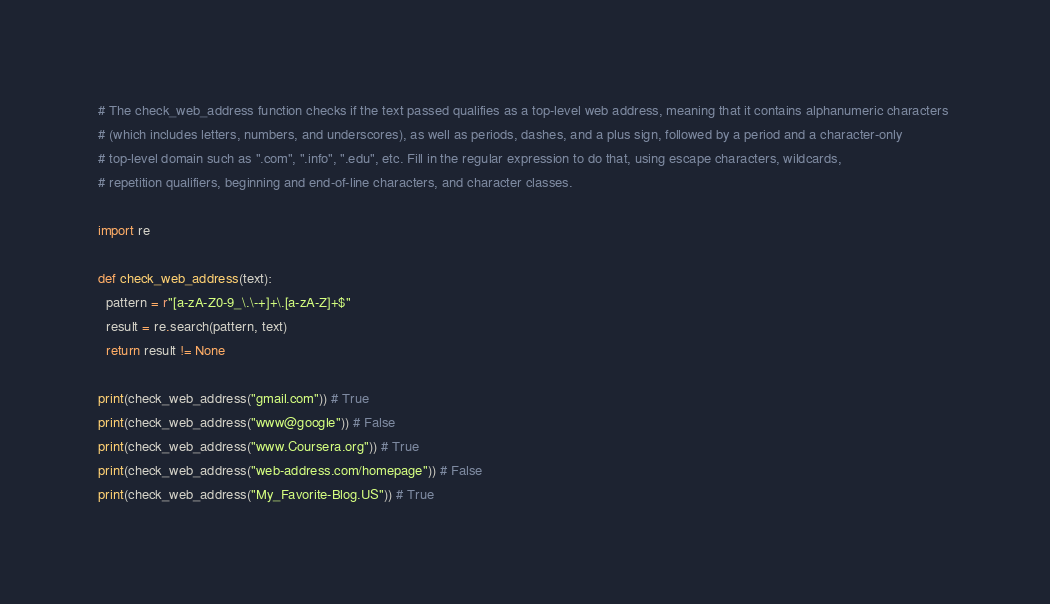<code> <loc_0><loc_0><loc_500><loc_500><_Python_># The check_web_address function checks if the text passed qualifies as a top-level web address, meaning that it contains alphanumeric characters 
# (which includes letters, numbers, and underscores), as well as periods, dashes, and a plus sign, followed by a period and a character-only 
# top-level domain such as ".com", ".info", ".edu", etc. Fill in the regular expression to do that, using escape characters, wildcards, 
# repetition qualifiers, beginning and end-of-line characters, and character classes.

import re

def check_web_address(text):
  pattern = r"[a-zA-Z0-9_\.\-+]+\.[a-zA-Z]+$"
  result = re.search(pattern, text)
  return result != None

print(check_web_address("gmail.com")) # True
print(check_web_address("www@google")) # False
print(check_web_address("www.Coursera.org")) # True
print(check_web_address("web-address.com/homepage")) # False
print(check_web_address("My_Favorite-Blog.US")) # True
</code> 